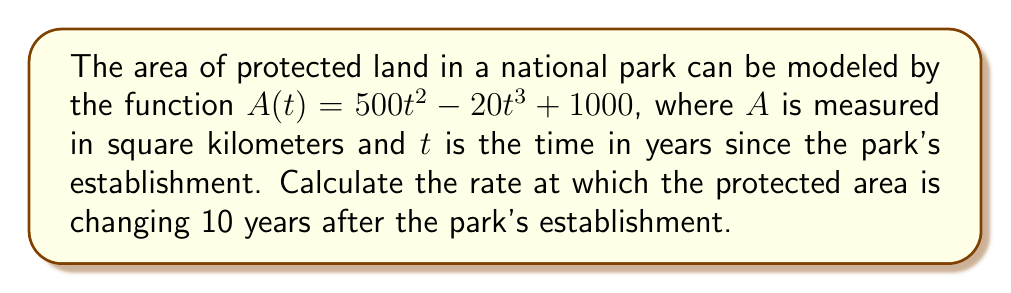Can you solve this math problem? To solve this problem, we need to follow these steps:

1) The rate of change of the protected land area is given by the derivative of $A(t)$ with respect to $t$.

2) Let's find the derivative $A'(t)$ using the power rule:

   $A'(t) = \frac{d}{dt}(500t^2 - 20t^3 + 1000)$
   $A'(t) = 1000t - 60t^2$

3) Now that we have the rate of change function, we need to evaluate it at $t = 10$ years:

   $A'(10) = 1000(10) - 60(10)^2$
   $A'(10) = 10000 - 60(100)$
   $A'(10) = 10000 - 6000$
   $A'(10) = 4000$

4) The units of the rate of change will be square kilometers per year (km²/year).

Therefore, 10 years after the park's establishment, the protected area is changing at a rate of 4000 km²/year.
Answer: 4000 km²/year 